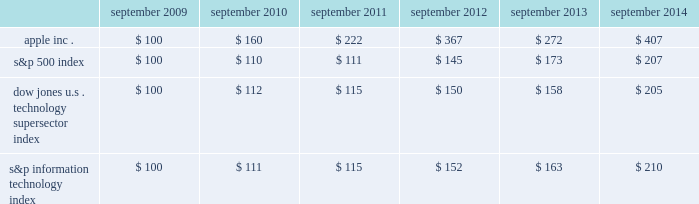Table of contents company stock performance the following graph shows a comparison of cumulative total shareholder return , calculated on a dividend reinvested basis , for the company , the s&p 500 index , the dow jones u.s .
Technology supersector index and the s&p information technology index for the five years ended september 27 , 2014 .
The company has added the s&p information technology index to the graph to capture the stock performance of companies whose products and services relate to those of the company .
The s&p information technology index replaces the s&p computer hardware index , which is no longer tracked by s&p .
The graph assumes $ 100 was invested in each of the company 2019s common stock , the s&p 500 index , the dow jones u.s .
Technology supersector index and the s&p information technology index as of the market close on september 25 , 2009 .
Note that historic stock price performance is not necessarily indicative of future stock price performance .
Copyright a9 2014 s&p , a division of the mcgraw-hill companies inc .
All rights reserved .
Copyright a9 2014 dow jones & co .
All rights reserved .
Apple inc .
| 2014 form 10-k | 23 * $ 100 invested on 9/25/09 in stock or index , including reinvestment of dividends .
Data points are the last day of each fiscal year for the company 2019s common stock and september 30th for indexes .
September september september september september september .

What was the difference in percentage of cumulative total shareholder return for the five year period ended september 2014 between apple inc . and the s&p 500 index? 
Computations: (((407 - 100) / 100) - ((207 - 100) / 100))
Answer: 2.0. 